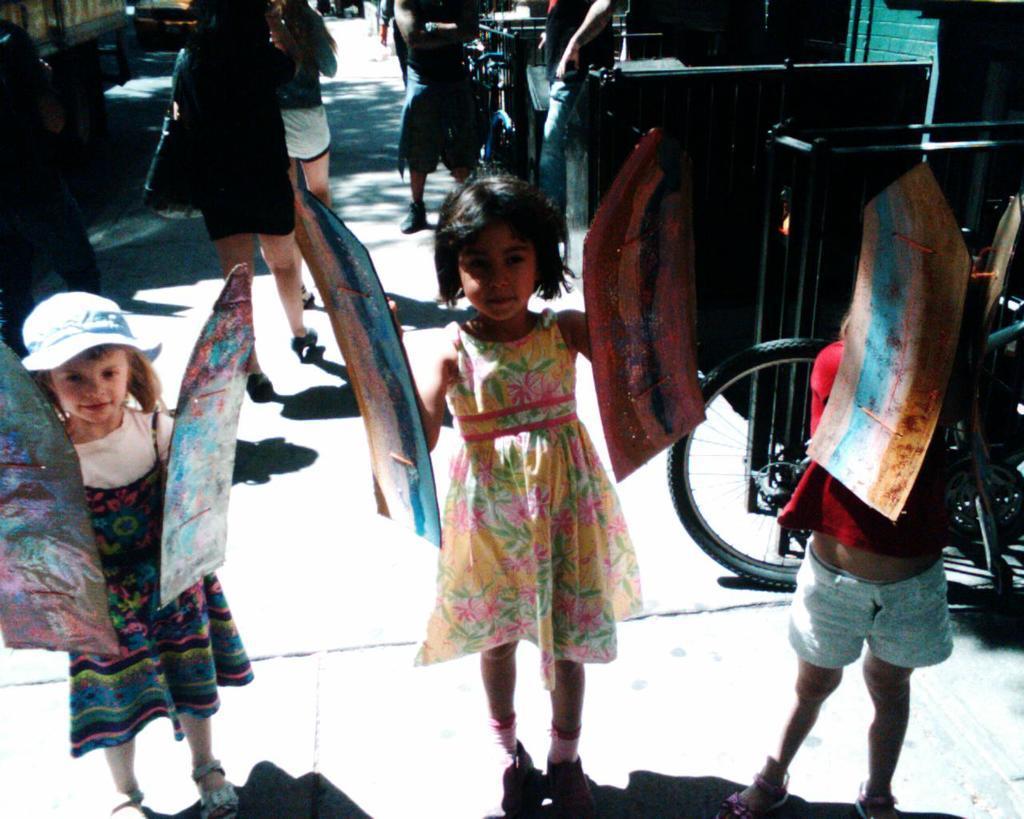Can you describe this image briefly? There are three kids standing on the road holding some objects on their hand. At background I can see a women walking,and I can see some vehicles moving on the road. At right of the image I can see a bicycle wheel. At background I can see two persons standing. 